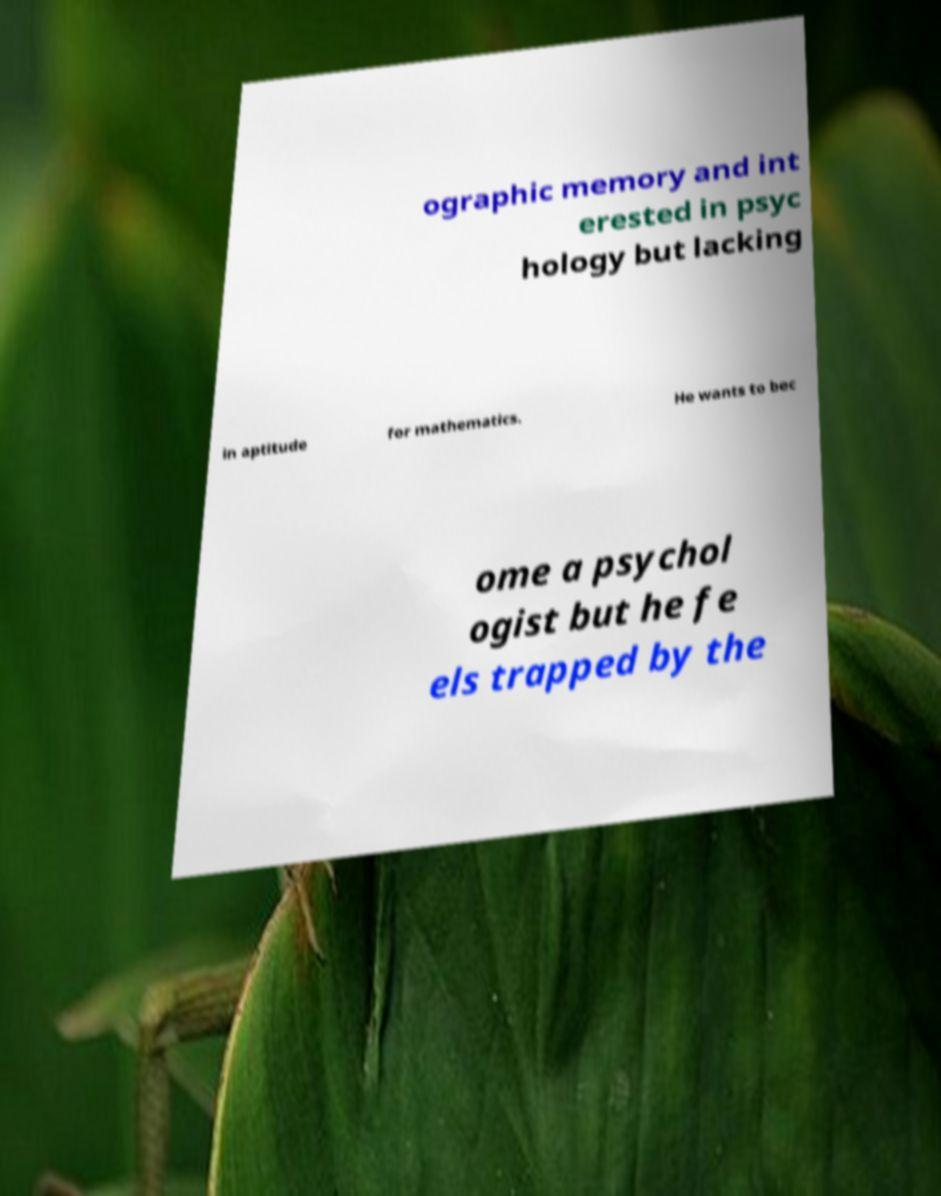What messages or text are displayed in this image? I need them in a readable, typed format. ographic memory and int erested in psyc hology but lacking in aptitude for mathematics. He wants to bec ome a psychol ogist but he fe els trapped by the 